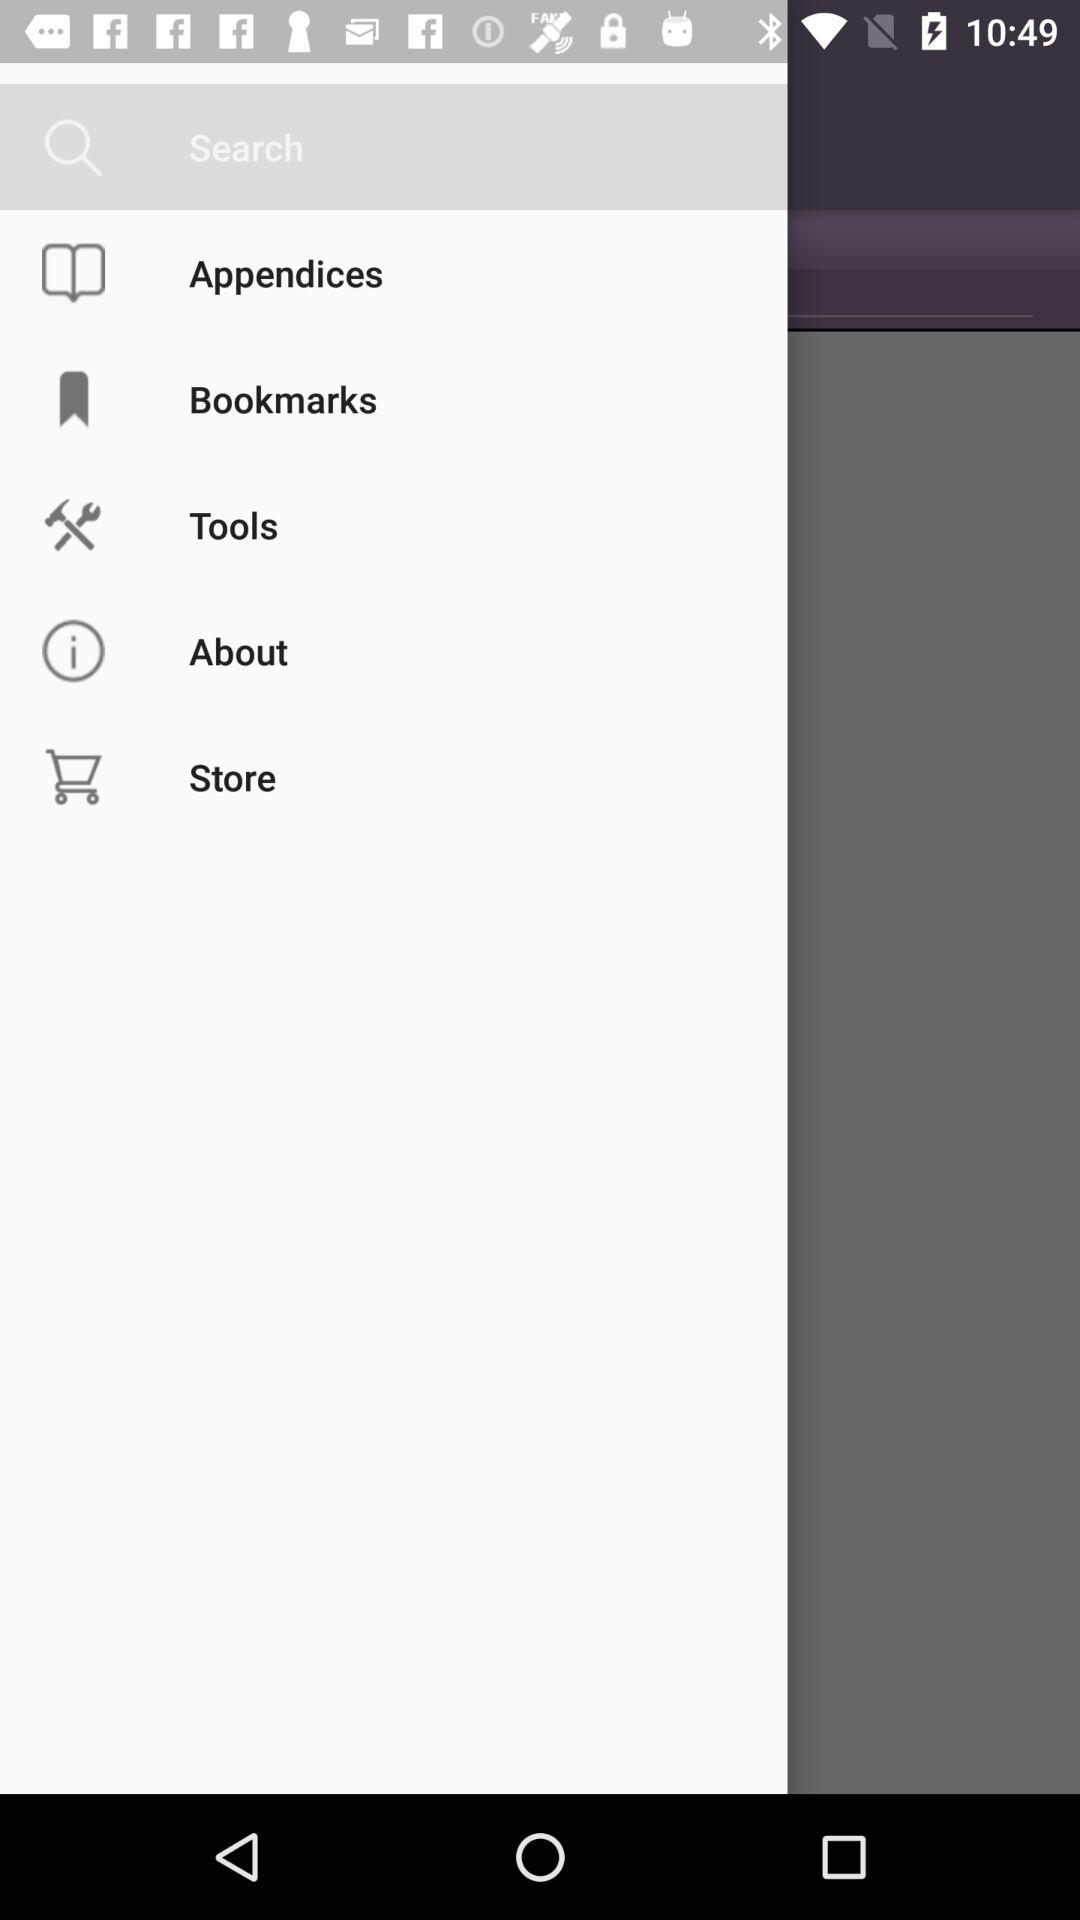What's the selected menu option? The selected option is "Search". 